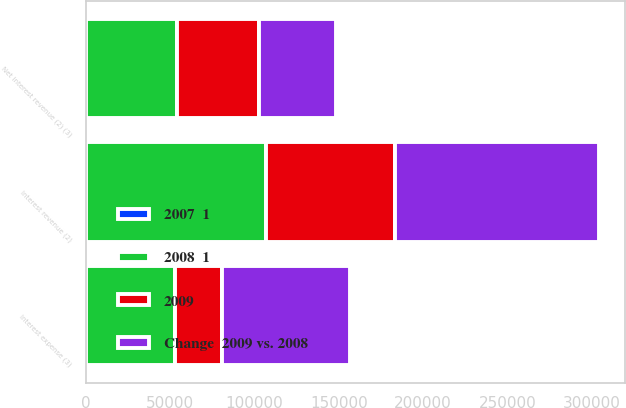Convert chart to OTSL. <chart><loc_0><loc_0><loc_500><loc_500><stacked_bar_chart><ecel><fcel>Interest revenue (2)<fcel>Interest expense (3)<fcel>Net interest revenue (2) (3)<nl><fcel>2009<fcel>76635<fcel>27721<fcel>48914<nl><fcel>2008  1<fcel>106499<fcel>52750<fcel>53749<nl><fcel>Change  2009 vs. 2008<fcel>121347<fcel>75958<fcel>45389<nl><fcel>2007  1<fcel>28<fcel>47<fcel>9<nl></chart> 